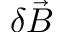<formula> <loc_0><loc_0><loc_500><loc_500>\delta \vec { B }</formula> 